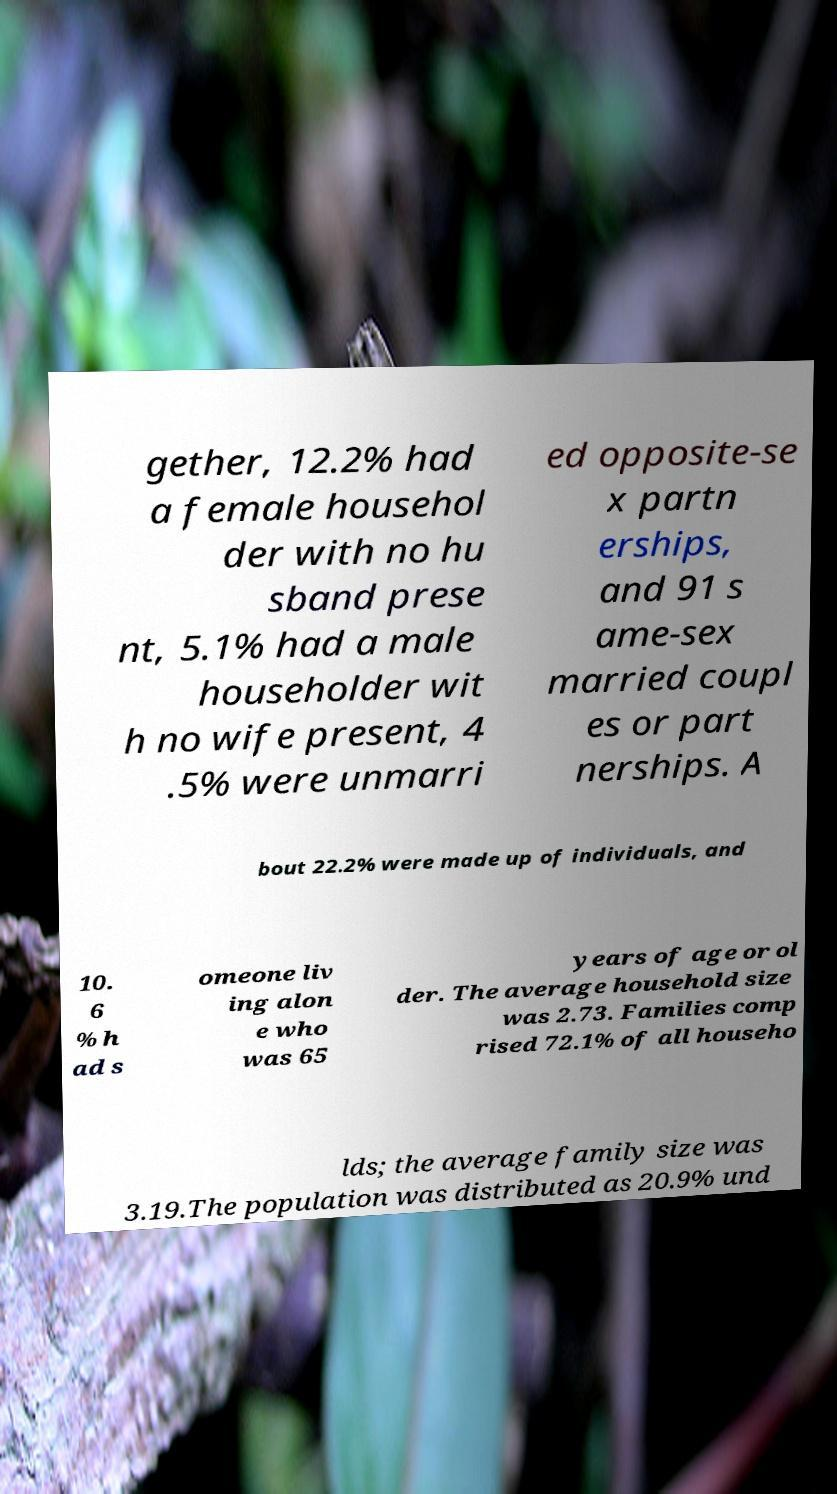Please read and relay the text visible in this image. What does it say? gether, 12.2% had a female househol der with no hu sband prese nt, 5.1% had a male householder wit h no wife present, 4 .5% were unmarri ed opposite-se x partn erships, and 91 s ame-sex married coupl es or part nerships. A bout 22.2% were made up of individuals, and 10. 6 % h ad s omeone liv ing alon e who was 65 years of age or ol der. The average household size was 2.73. Families comp rised 72.1% of all househo lds; the average family size was 3.19.The population was distributed as 20.9% und 